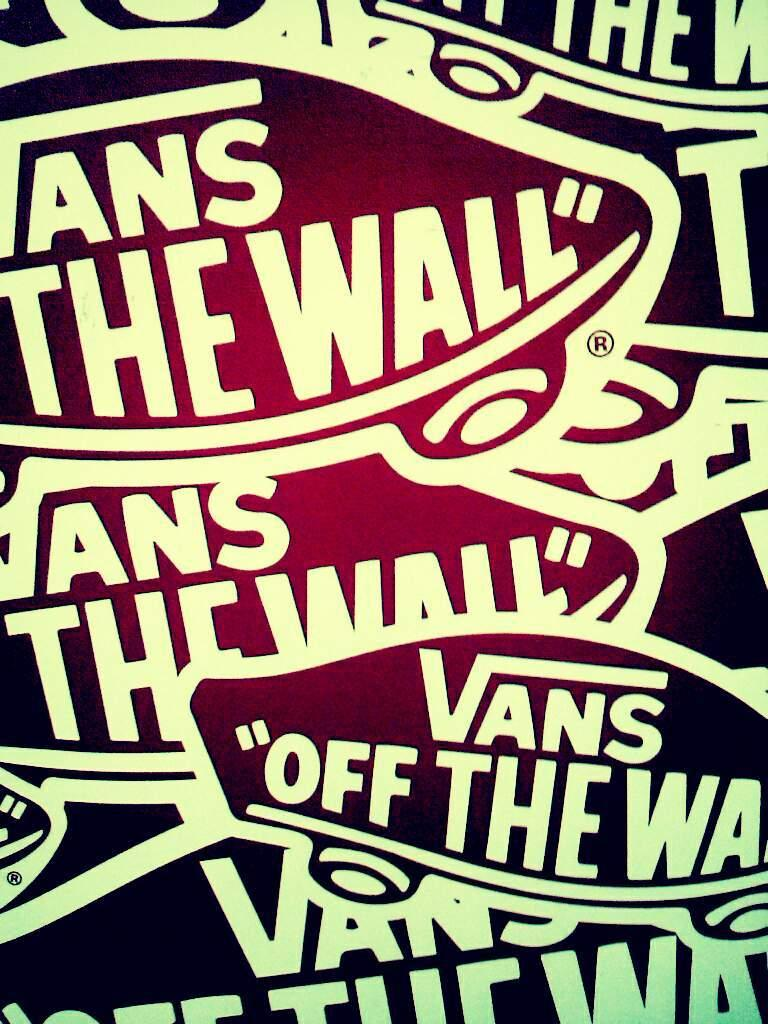<image>
Render a clear and concise summary of the photo. A purple sign has Vans and Off the wall on it. 